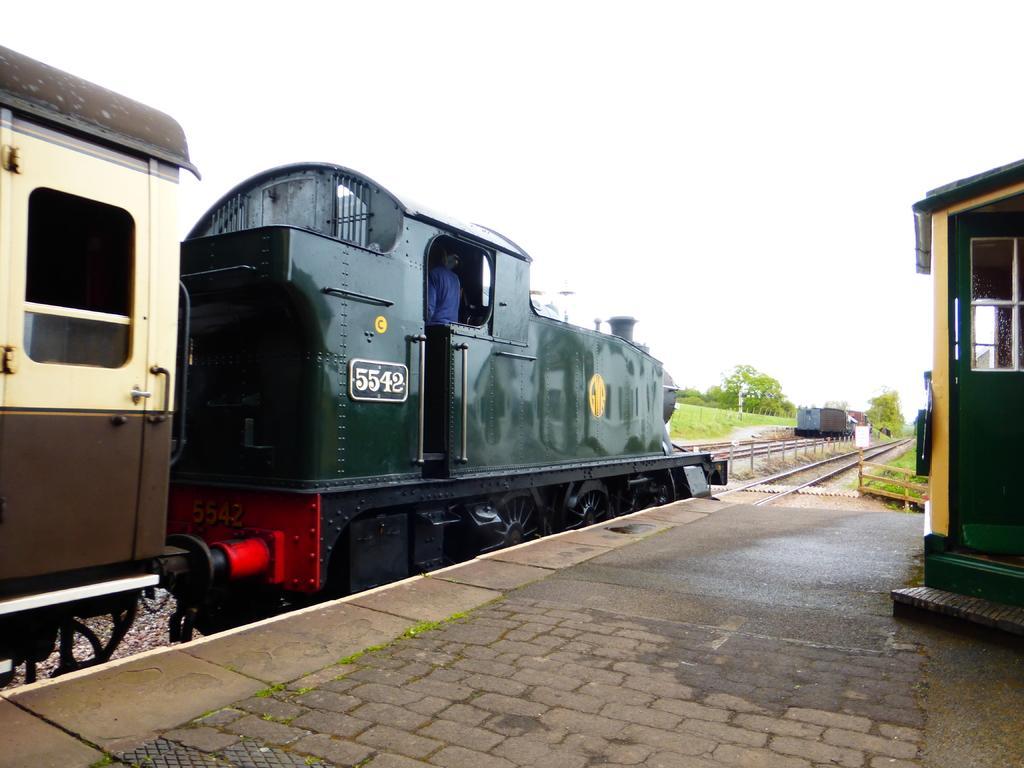Can you describe this image briefly? In this image there is a train on the railway track. Beside the train there is a platform on which there is a house. At the top there is the sky. In the background there are few plants and trees beside the track. 